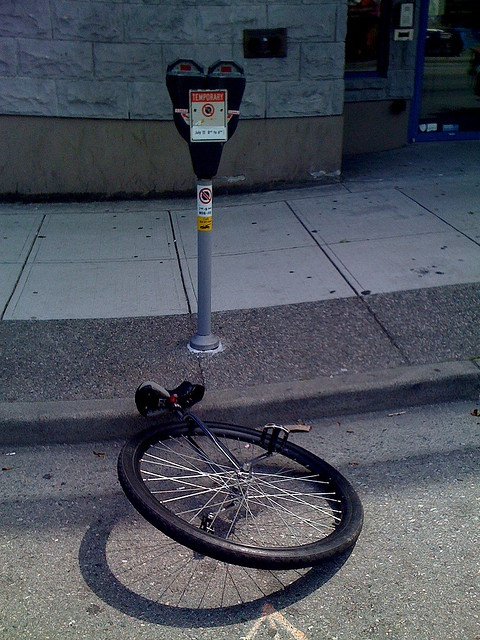Describe the objects in this image and their specific colors. I can see bicycle in navy, black, gray, and darkgray tones and parking meter in navy, black, gray, and darkgray tones in this image. 